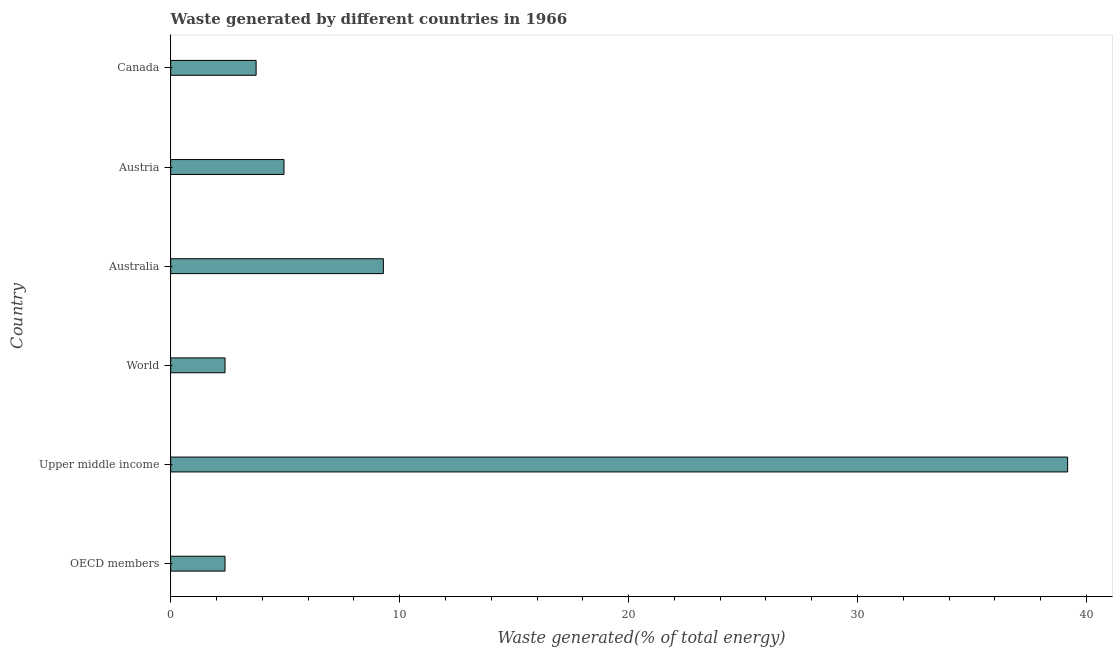Does the graph contain any zero values?
Your response must be concise. No. Does the graph contain grids?
Your answer should be very brief. No. What is the title of the graph?
Your answer should be compact. Waste generated by different countries in 1966. What is the label or title of the X-axis?
Offer a terse response. Waste generated(% of total energy). What is the label or title of the Y-axis?
Give a very brief answer. Country. What is the amount of waste generated in Upper middle income?
Make the answer very short. 39.18. Across all countries, what is the maximum amount of waste generated?
Offer a terse response. 39.18. Across all countries, what is the minimum amount of waste generated?
Your answer should be compact. 2.37. In which country was the amount of waste generated maximum?
Your answer should be compact. Upper middle income. What is the sum of the amount of waste generated?
Your response must be concise. 61.89. What is the difference between the amount of waste generated in Upper middle income and World?
Your response must be concise. 36.8. What is the average amount of waste generated per country?
Your answer should be compact. 10.31. What is the median amount of waste generated?
Your answer should be compact. 4.34. What is the ratio of the amount of waste generated in Canada to that in World?
Give a very brief answer. 1.57. What is the difference between the highest and the second highest amount of waste generated?
Offer a very short reply. 29.89. What is the difference between the highest and the lowest amount of waste generated?
Provide a succinct answer. 36.81. How many countries are there in the graph?
Keep it short and to the point. 6. What is the Waste generated(% of total energy) in OECD members?
Ensure brevity in your answer.  2.37. What is the Waste generated(% of total energy) in Upper middle income?
Provide a succinct answer. 39.18. What is the Waste generated(% of total energy) of World?
Keep it short and to the point. 2.37. What is the Waste generated(% of total energy) in Australia?
Provide a short and direct response. 9.29. What is the Waste generated(% of total energy) in Austria?
Ensure brevity in your answer.  4.95. What is the Waste generated(% of total energy) of Canada?
Ensure brevity in your answer.  3.73. What is the difference between the Waste generated(% of total energy) in OECD members and Upper middle income?
Ensure brevity in your answer.  -36.81. What is the difference between the Waste generated(% of total energy) in OECD members and Australia?
Your answer should be compact. -6.92. What is the difference between the Waste generated(% of total energy) in OECD members and Austria?
Your answer should be compact. -2.58. What is the difference between the Waste generated(% of total energy) in OECD members and Canada?
Your answer should be compact. -1.36. What is the difference between the Waste generated(% of total energy) in Upper middle income and World?
Ensure brevity in your answer.  36.81. What is the difference between the Waste generated(% of total energy) in Upper middle income and Australia?
Your answer should be very brief. 29.89. What is the difference between the Waste generated(% of total energy) in Upper middle income and Austria?
Make the answer very short. 34.23. What is the difference between the Waste generated(% of total energy) in Upper middle income and Canada?
Your answer should be compact. 35.45. What is the difference between the Waste generated(% of total energy) in World and Australia?
Your response must be concise. -6.92. What is the difference between the Waste generated(% of total energy) in World and Austria?
Provide a short and direct response. -2.58. What is the difference between the Waste generated(% of total energy) in World and Canada?
Make the answer very short. -1.36. What is the difference between the Waste generated(% of total energy) in Australia and Austria?
Ensure brevity in your answer.  4.34. What is the difference between the Waste generated(% of total energy) in Australia and Canada?
Your response must be concise. 5.56. What is the difference between the Waste generated(% of total energy) in Austria and Canada?
Offer a terse response. 1.22. What is the ratio of the Waste generated(% of total energy) in OECD members to that in Upper middle income?
Offer a terse response. 0.06. What is the ratio of the Waste generated(% of total energy) in OECD members to that in Australia?
Give a very brief answer. 0.26. What is the ratio of the Waste generated(% of total energy) in OECD members to that in Austria?
Provide a short and direct response. 0.48. What is the ratio of the Waste generated(% of total energy) in OECD members to that in Canada?
Keep it short and to the point. 0.64. What is the ratio of the Waste generated(% of total energy) in Upper middle income to that in World?
Offer a very short reply. 16.52. What is the ratio of the Waste generated(% of total energy) in Upper middle income to that in Australia?
Your answer should be compact. 4.22. What is the ratio of the Waste generated(% of total energy) in Upper middle income to that in Austria?
Offer a very short reply. 7.92. What is the ratio of the Waste generated(% of total energy) in Upper middle income to that in Canada?
Offer a terse response. 10.5. What is the ratio of the Waste generated(% of total energy) in World to that in Australia?
Ensure brevity in your answer.  0.26. What is the ratio of the Waste generated(% of total energy) in World to that in Austria?
Your response must be concise. 0.48. What is the ratio of the Waste generated(% of total energy) in World to that in Canada?
Offer a terse response. 0.64. What is the ratio of the Waste generated(% of total energy) in Australia to that in Austria?
Offer a very short reply. 1.88. What is the ratio of the Waste generated(% of total energy) in Australia to that in Canada?
Your response must be concise. 2.49. What is the ratio of the Waste generated(% of total energy) in Austria to that in Canada?
Your response must be concise. 1.33. 